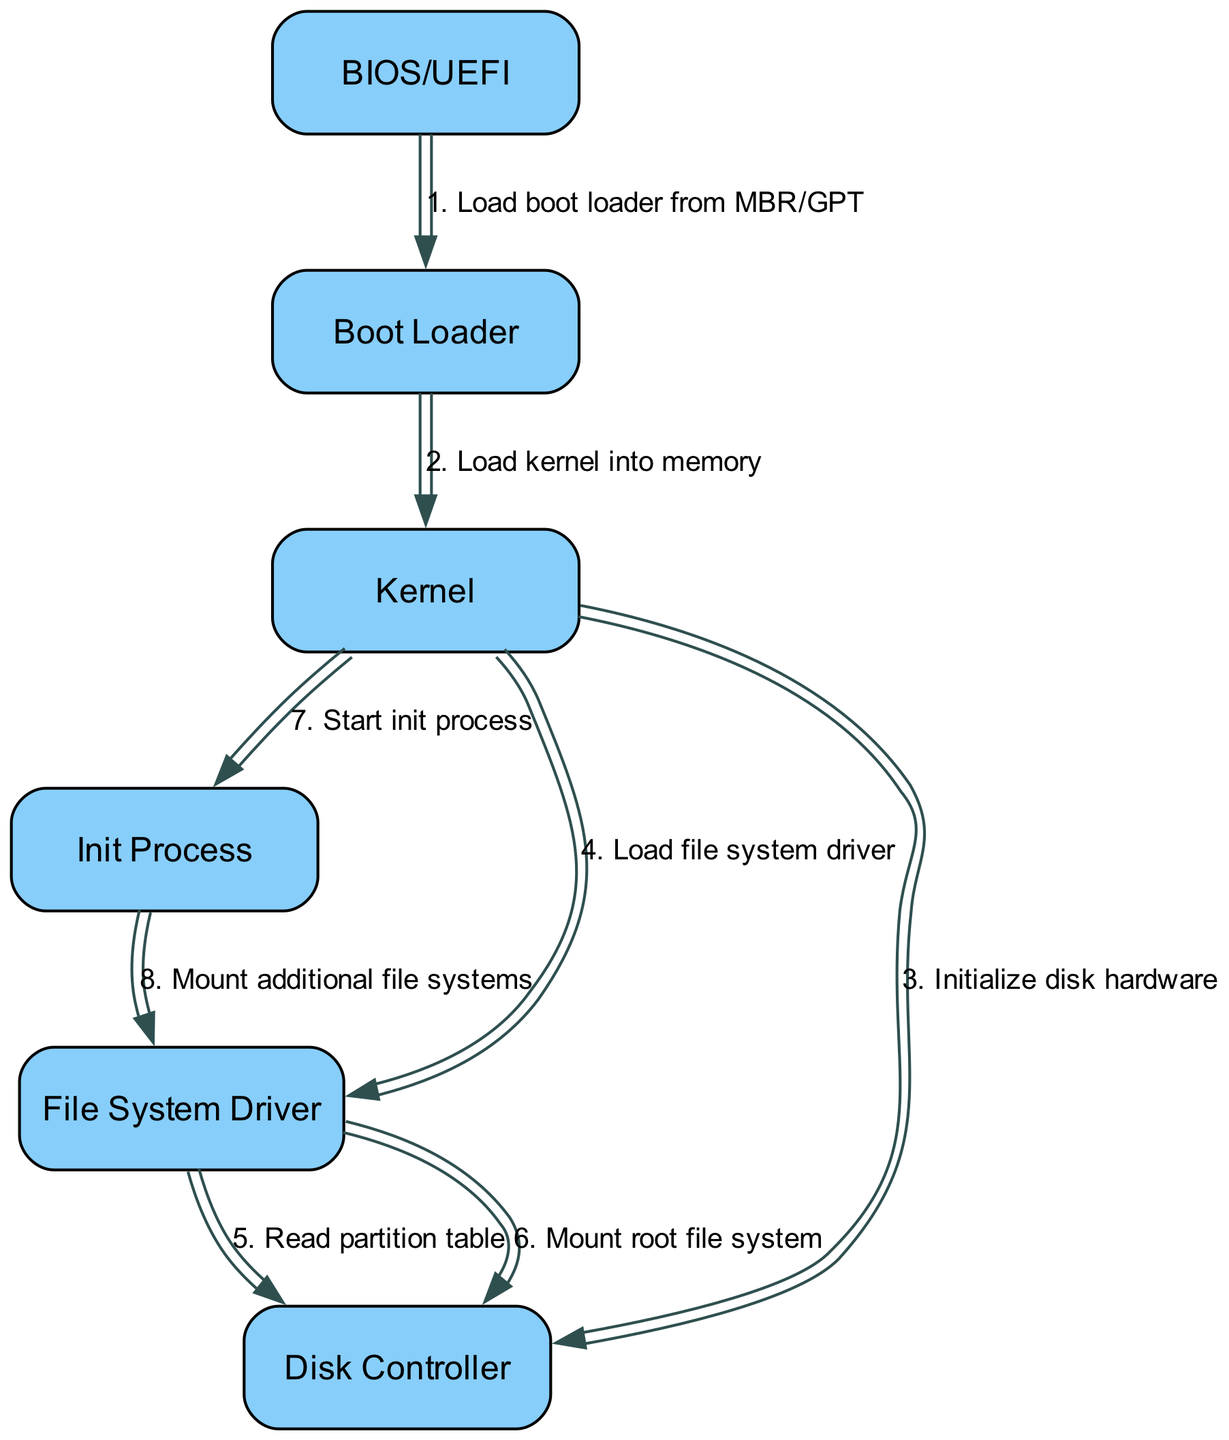What is the first action performed in the boot sequence? The first action shown in the diagram is the BIOS/UEFI loading the boot loader from MBR/GPT. This is indicated as the first message in the sequence.
Answer: Load boot loader from MBR/GPT How many participants are involved in the boot sequence? The diagram includes a total of six participants involved in the sequence: BIOS/UEFI, Boot Loader, Kernel, Init Process, File System Driver, and Disk Controller.
Answer: Six What does the Boot Loader do after receiving control from BIOS/UEFI? The Boot Loader's action after receiving control is to load the Kernel into memory, which is illustrated by the message from Boot Loader to Kernel.
Answer: Load kernel into memory Which component initializes the disk hardware? The Kernel is responsible for initializing the disk hardware, as depicted by the message from the Kernel to the Disk Controller in the sequence.
Answer: Kernel What are the two actions taken by the File System Driver in the sequence? The File System Driver takes two actions: first, it reads the partition table, and second, it mounts the root file system, which can be traced through its consecutive messages to the Disk Controller.
Answer: Read partition table, Mount root file system What triggers the initiation of the Init Process? The initiation of the Init Process is triggered by the Kernel, which sends a message specifically stating to start the Init Process to the Init Process. This can be found as a distinct step following the loading of the file system driver.
Answer: Start init process Which participant is responsible for mounting additional file systems? The Init Process is responsible for this action, as shown in the diagram where it sends a message to the File System Driver to mount additional file systems.
Answer: Init Process What is the total number of messages exchanged in the sequence? There are a total of eight messages exchanged in the sequence, indicating the various actions between the participants from the loading of the boot loader to the mounting of file systems.
Answer: Eight 